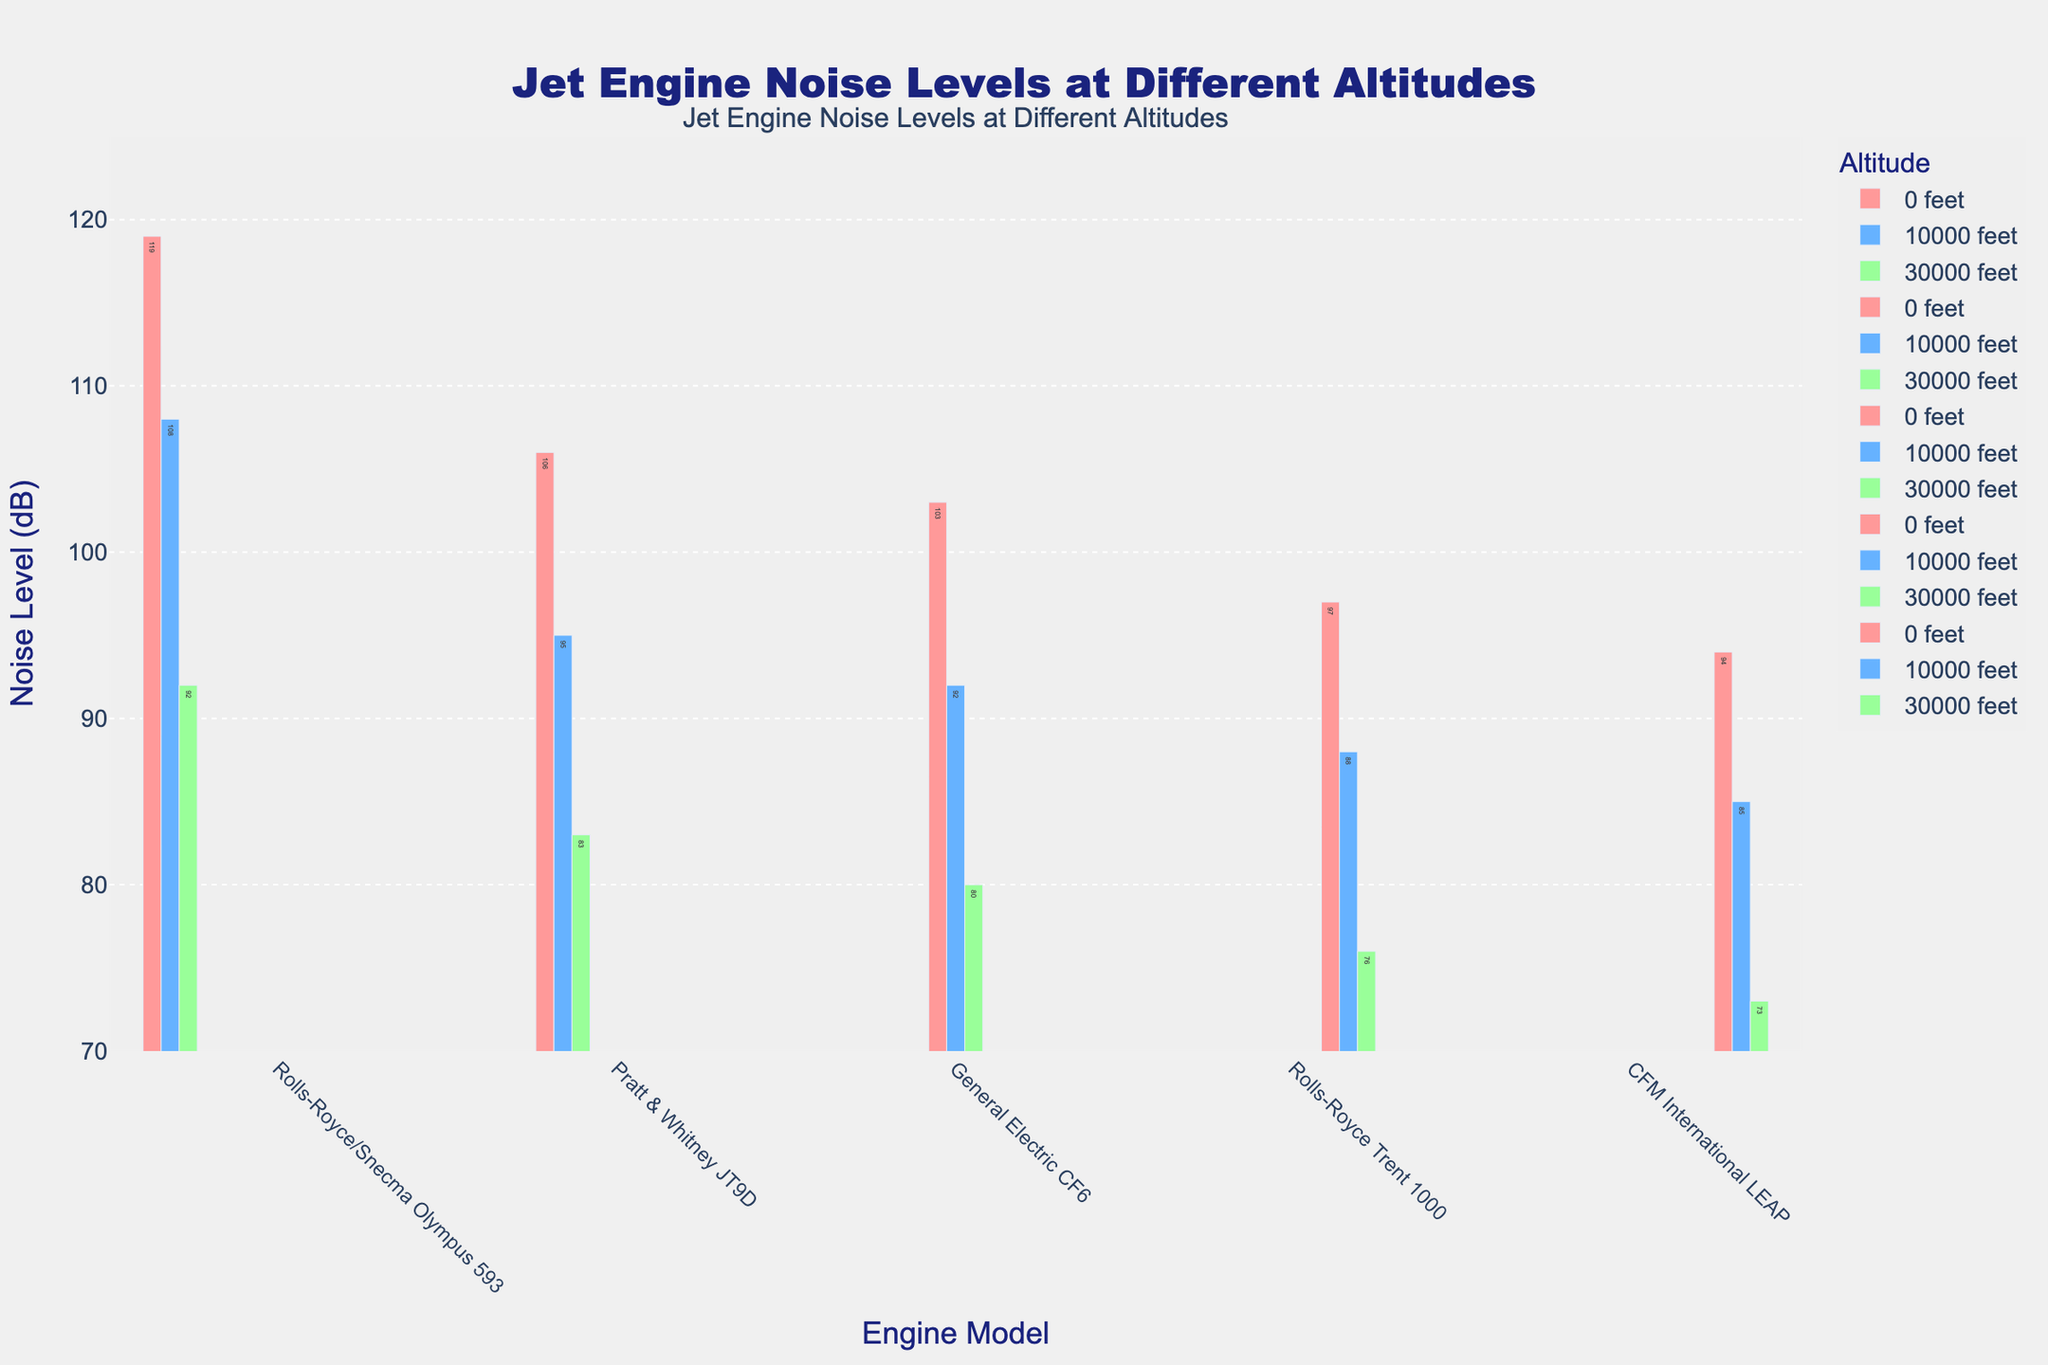What is the noise level of the Rolls-Royce/Snecma Olympus 593 engine at 0 feet? The chart's bar corresponding to the Rolls-Royce/Snecma Olympus 593 engine at 0 feet is marked in red and shows the noise level directly.
Answer: 119 dB Which engine has the highest noise level at 30,000 feet? By comparing the green bars (representing 30,000 feet altitude) for each engine, you can find the one with the highest value. The Rolls-Royce/Snecma Olympus 593 has the highest green bar at 30,000 feet.
Answer: Rolls-Royce/Snecma Olympus 593 How does the noise level of the CFM International LEAP engine at 10,000 feet compare to the Pratt & Whitney JT9D engine at the same altitude? Look at the blue bars (representing 10,000 feet) for CFM International LEAP and Pratt & Whitney JT9D. The bar for the CFM International LEAP is slightly shorter than the Pratt & Whitney JT9D.
Answer: CFM International LEAP is quieter What is the average noise level of the General Electric CF6 engine across all altitudes? Sum the noise levels of the General Electric CF6 at 0, 10,000, and 30,000 feet (103 dB, 92 dB, 80 dB) and divide by 3: (103 + 92 + 80) / 3 = 275 / 3.
Answer: 91.67 dB Which altitude has the lowest noise level for the Rolls-Royce Trent 1000 engine? Compare the bars for Rolls-Royce Trent 1000 engine across different altitudes by looking at the noise levels indicated: 0 feet (97 dB), 10,000 feet (88 dB), 30,000 feet (76 dB).
Answer: 30,000 feet How much does the noise level decrease for the Pratt & Whitney JT9D engine from 0 feet to 30,000 feet? Subtract the noise level at 30,000 feet from 0 feet for the Pratt & Whitney JT9D engine: 106 dB - 83 dB.
Answer: 23 dB Which engine exhibits the smallest change in noise levels from 0 feet to 30,000 feet? Calculate the noise level difference at 0 feet and 30,000 feet for each engine. The smallest difference indicates the engine with the smallest change: Rolls-Royce/Snecma Olympus 593 (119-92=27), Pratt & Whitney JT9D (106-83=23), General Electric CF6 (103-80=23), Rolls-Royce Trent 1000 (97-76=21), CFM International LEAP (94-73=21).
Answer: Rolls-Royce Trent 1000 and CFM International LEAP Which engine has the lowest noise level at 0 feet? Compare the red bars representing 0 feet noise levels of all engines and find the one with the lowest value. The CFM International LEAP has the shortest red bar at 0 feet.
Answer: CFM International LEAP 